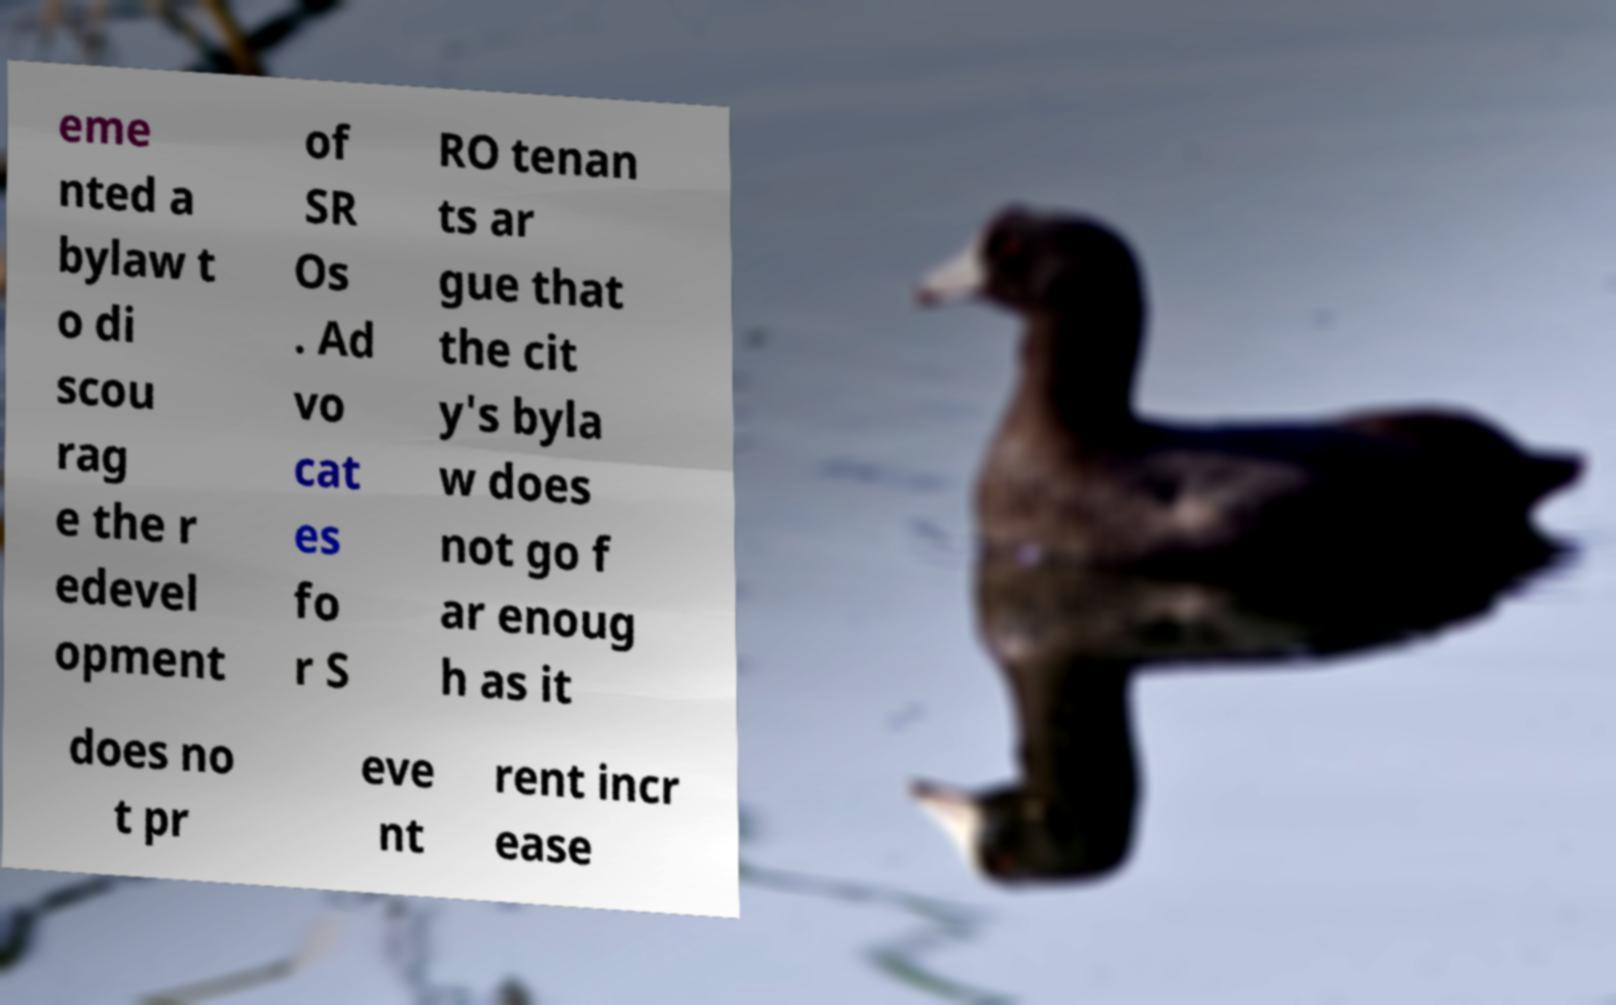I need the written content from this picture converted into text. Can you do that? eme nted a bylaw t o di scou rag e the r edevel opment of SR Os . Ad vo cat es fo r S RO tenan ts ar gue that the cit y's byla w does not go f ar enoug h as it does no t pr eve nt rent incr ease 